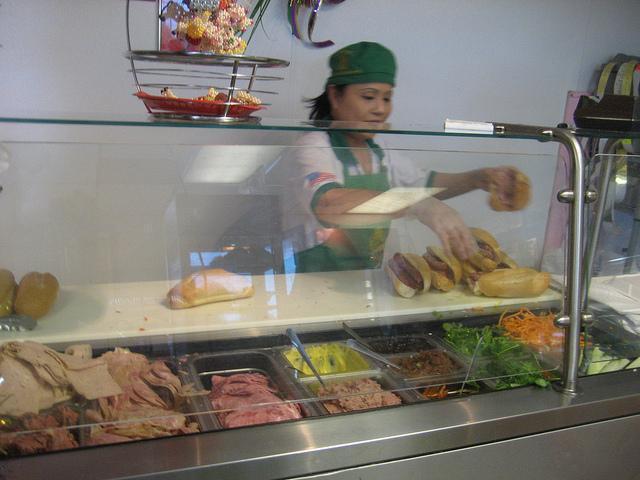How many hot dogs are in the photo?
Give a very brief answer. 2. 